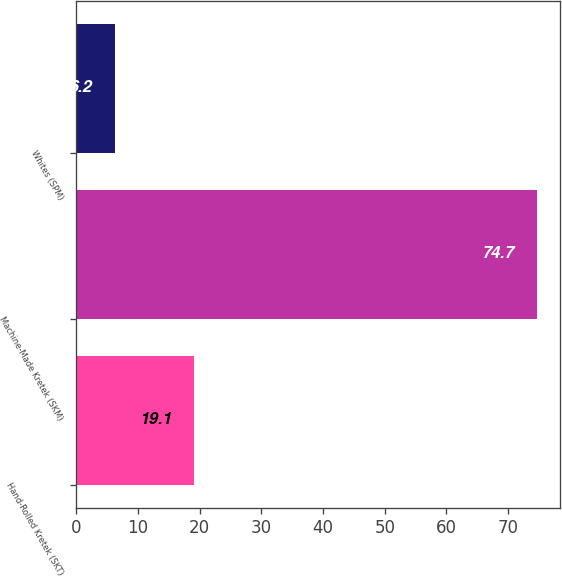Convert chart to OTSL. <chart><loc_0><loc_0><loc_500><loc_500><bar_chart><fcel>Hand-Rolled Kretek (SKT)<fcel>Machine-Made Kretek (SKM)<fcel>Whites (SPM)<nl><fcel>19.1<fcel>74.7<fcel>6.2<nl></chart> 